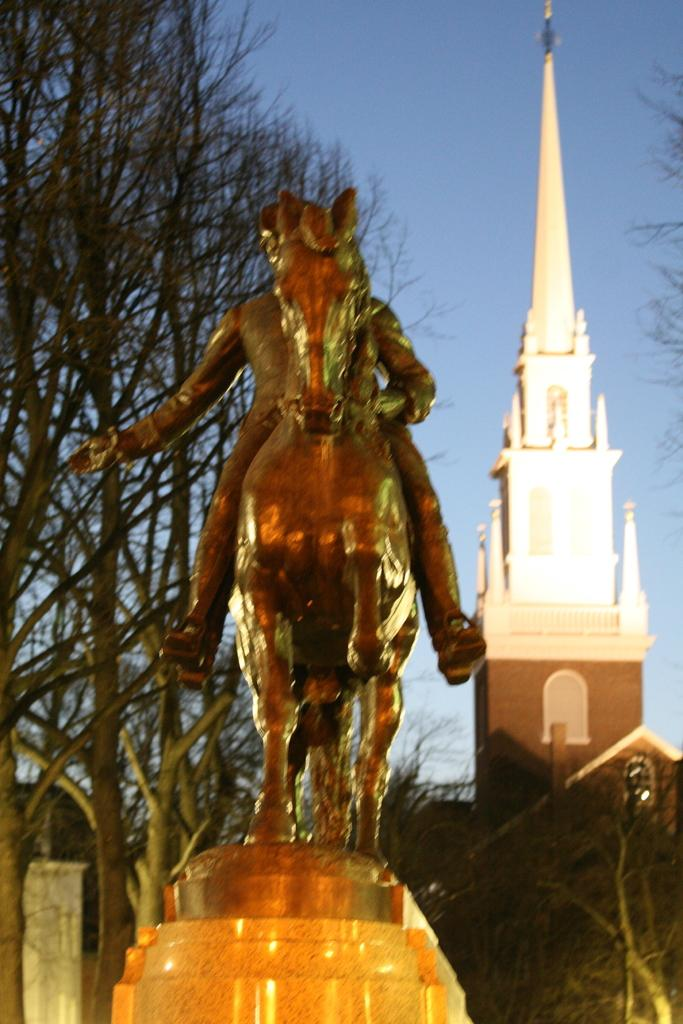What is the main subject in the image? There is a statue in the image. What other structures or elements can be seen in the image? There is a building and trees in the image. Are there any other objects or features in the image? Yes, there are other objects in the image. What can be seen in the background of the image? The sky is visible in the background of the image. What type of pancake is being served by the guide in the image? There is no guide or pancake present in the image. What kind of mask is the statue wearing in the image? The statue in the image is not wearing a mask. 